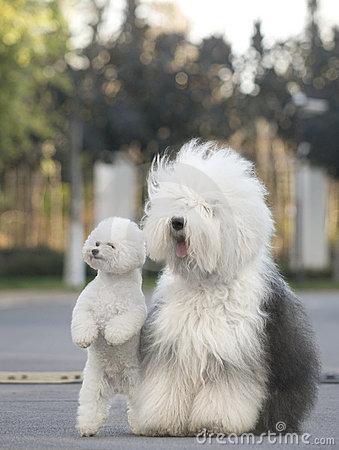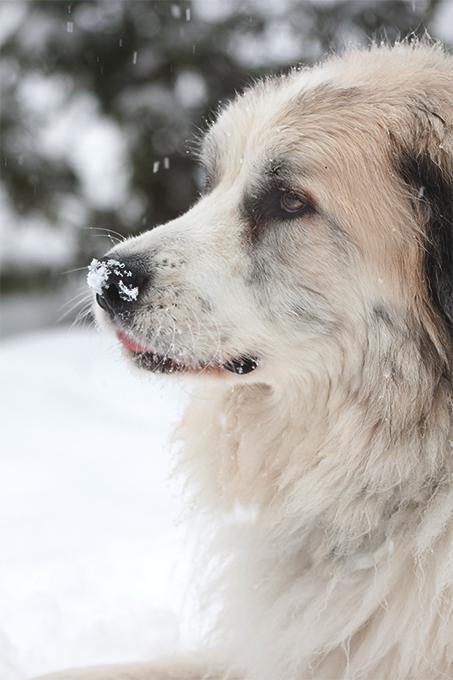The first image is the image on the left, the second image is the image on the right. Evaluate the accuracy of this statement regarding the images: "In one image there is a white dog outside in the grass.". Is it true? Answer yes or no. No. The first image is the image on the left, the second image is the image on the right. Given the left and right images, does the statement "There is at least one dog not in the grass" hold true? Answer yes or no. Yes. 